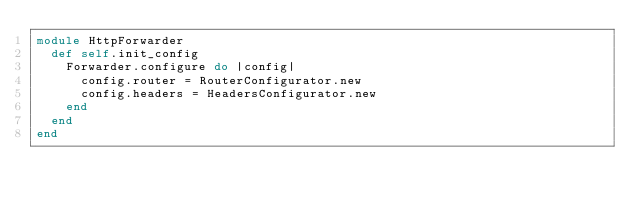Convert code to text. <code><loc_0><loc_0><loc_500><loc_500><_Ruby_>module HttpForwarder
  def self.init_config
    Forwarder.configure do |config|
      config.router = RouterConfigurator.new
      config.headers = HeadersConfigurator.new
    end
  end
end
</code> 